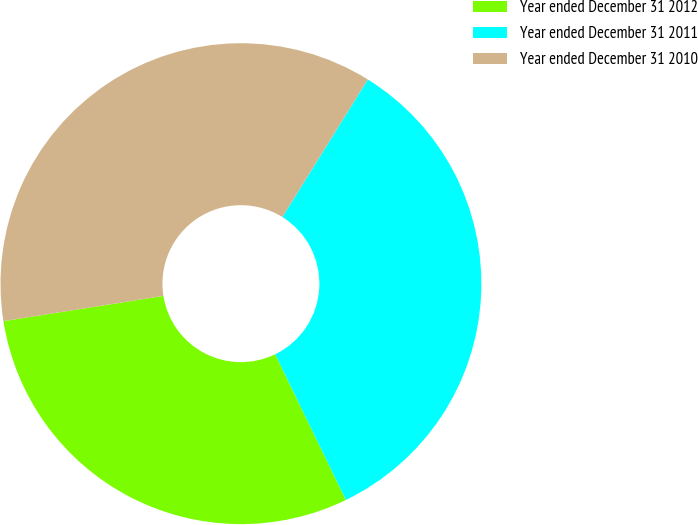Convert chart. <chart><loc_0><loc_0><loc_500><loc_500><pie_chart><fcel>Year ended December 31 2012<fcel>Year ended December 31 2011<fcel>Year ended December 31 2010<nl><fcel>29.7%<fcel>33.96%<fcel>36.34%<nl></chart> 